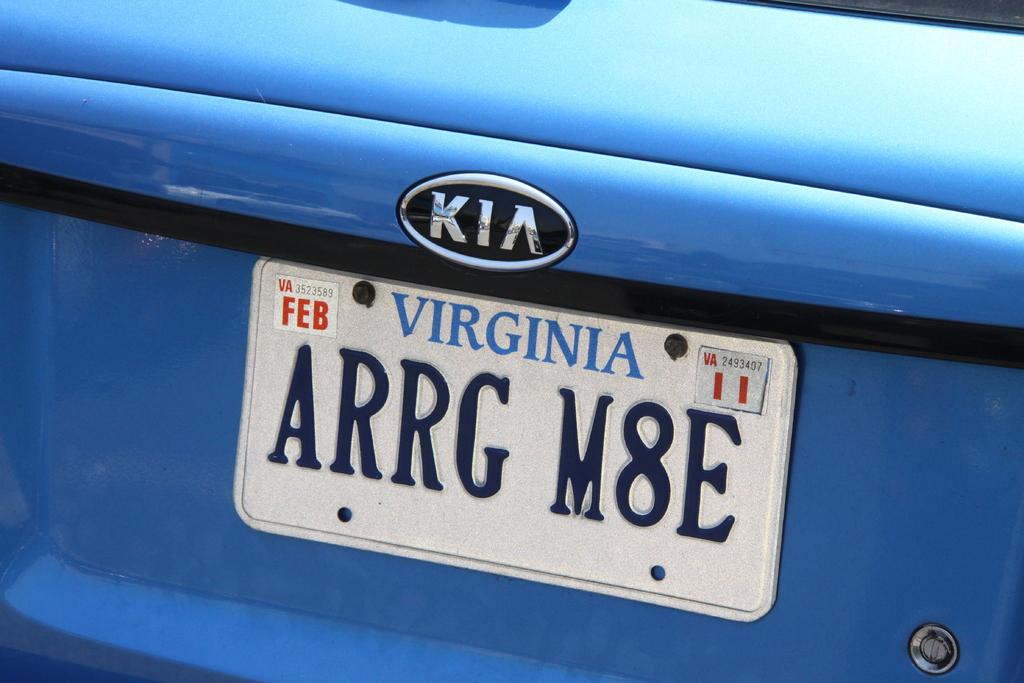What brand of car is this?
Your answer should be compact. Kia. 